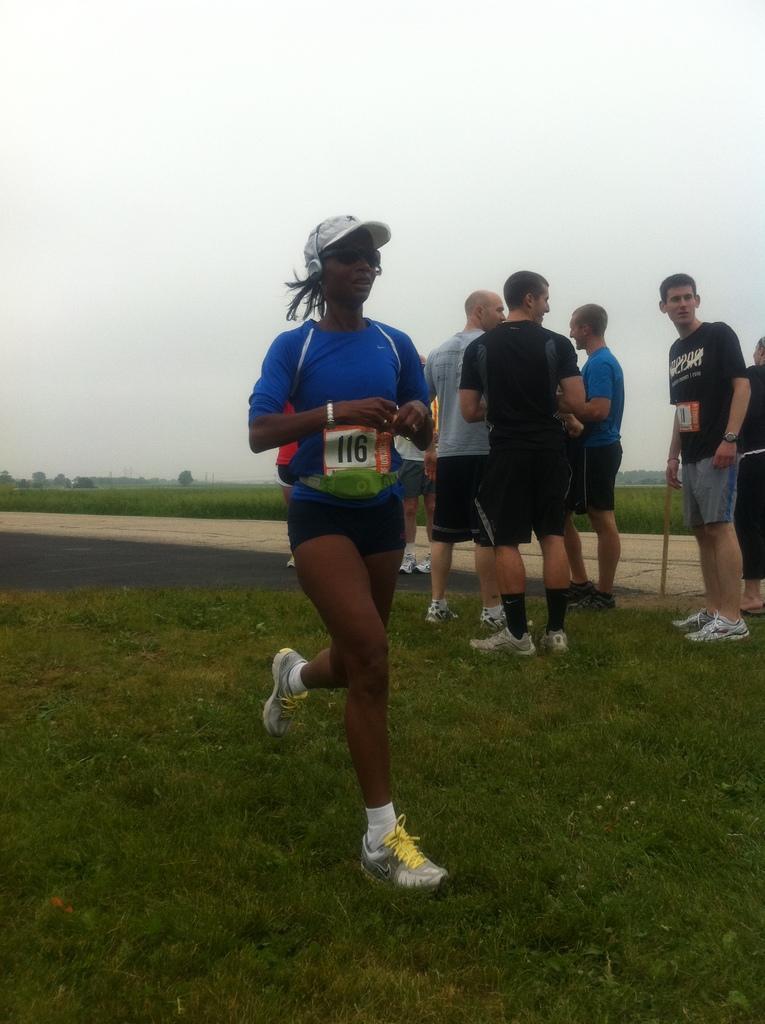Please provide a concise description of this image. In this image I can see some grass, few persons standing, the ground and few trees. In the background I can see the sky. 